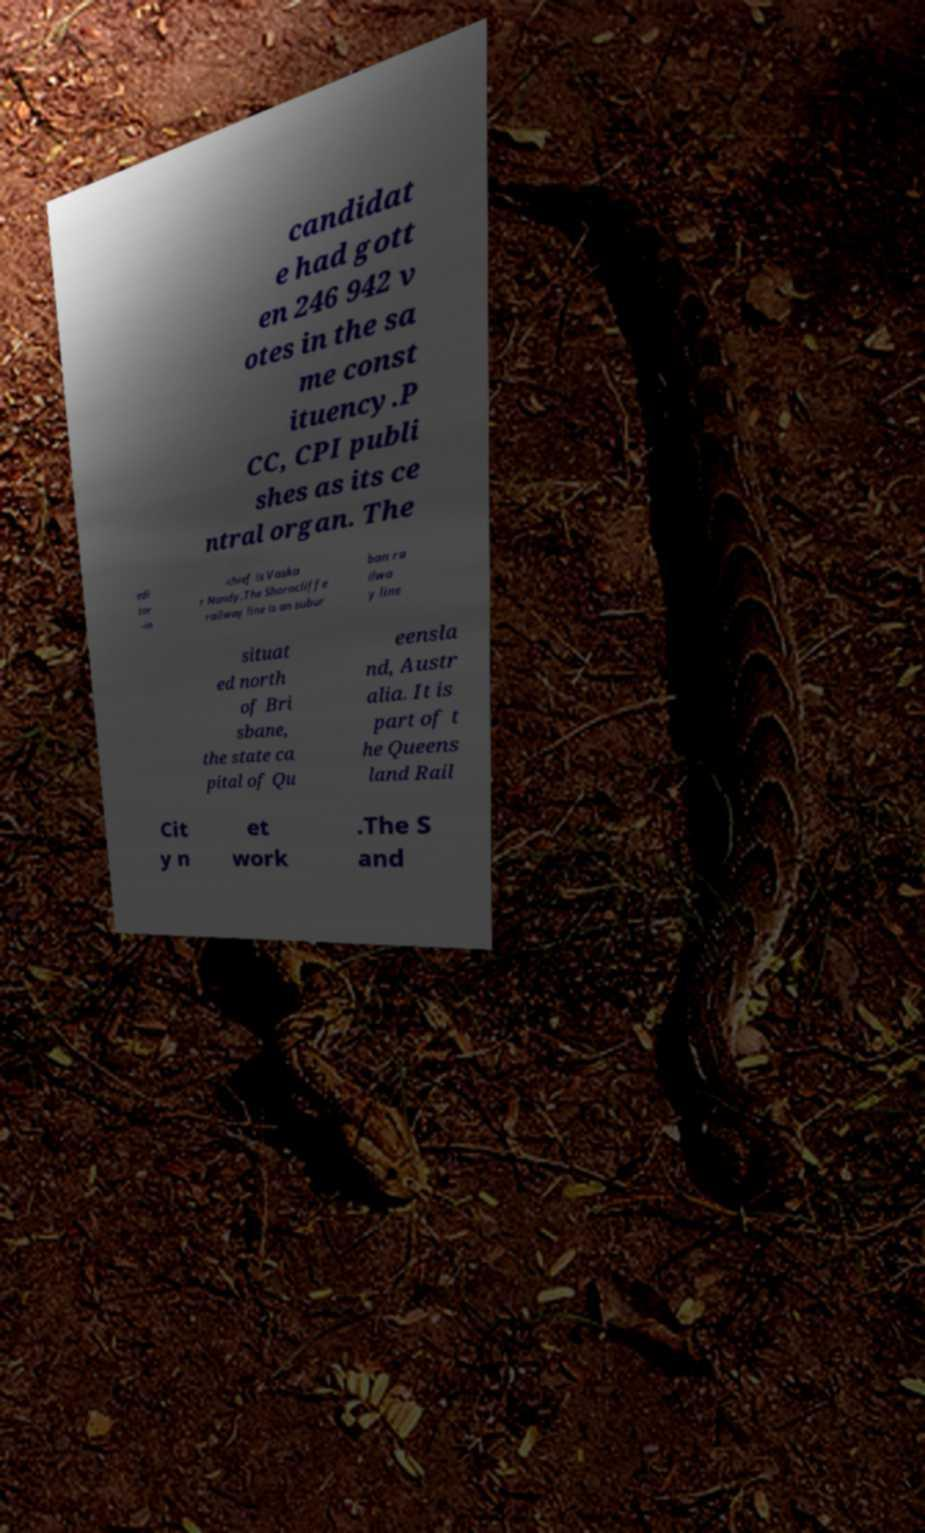Can you read and provide the text displayed in the image?This photo seems to have some interesting text. Can you extract and type it out for me? candidat e had gott en 246 942 v otes in the sa me const ituency.P CC, CPI publi shes as its ce ntral organ. The edi tor -in -chief is Vaska r Nandy.The Shorncliffe railway line is an subur ban ra ilwa y line situat ed north of Bri sbane, the state ca pital of Qu eensla nd, Austr alia. It is part of t he Queens land Rail Cit y n et work .The S and 